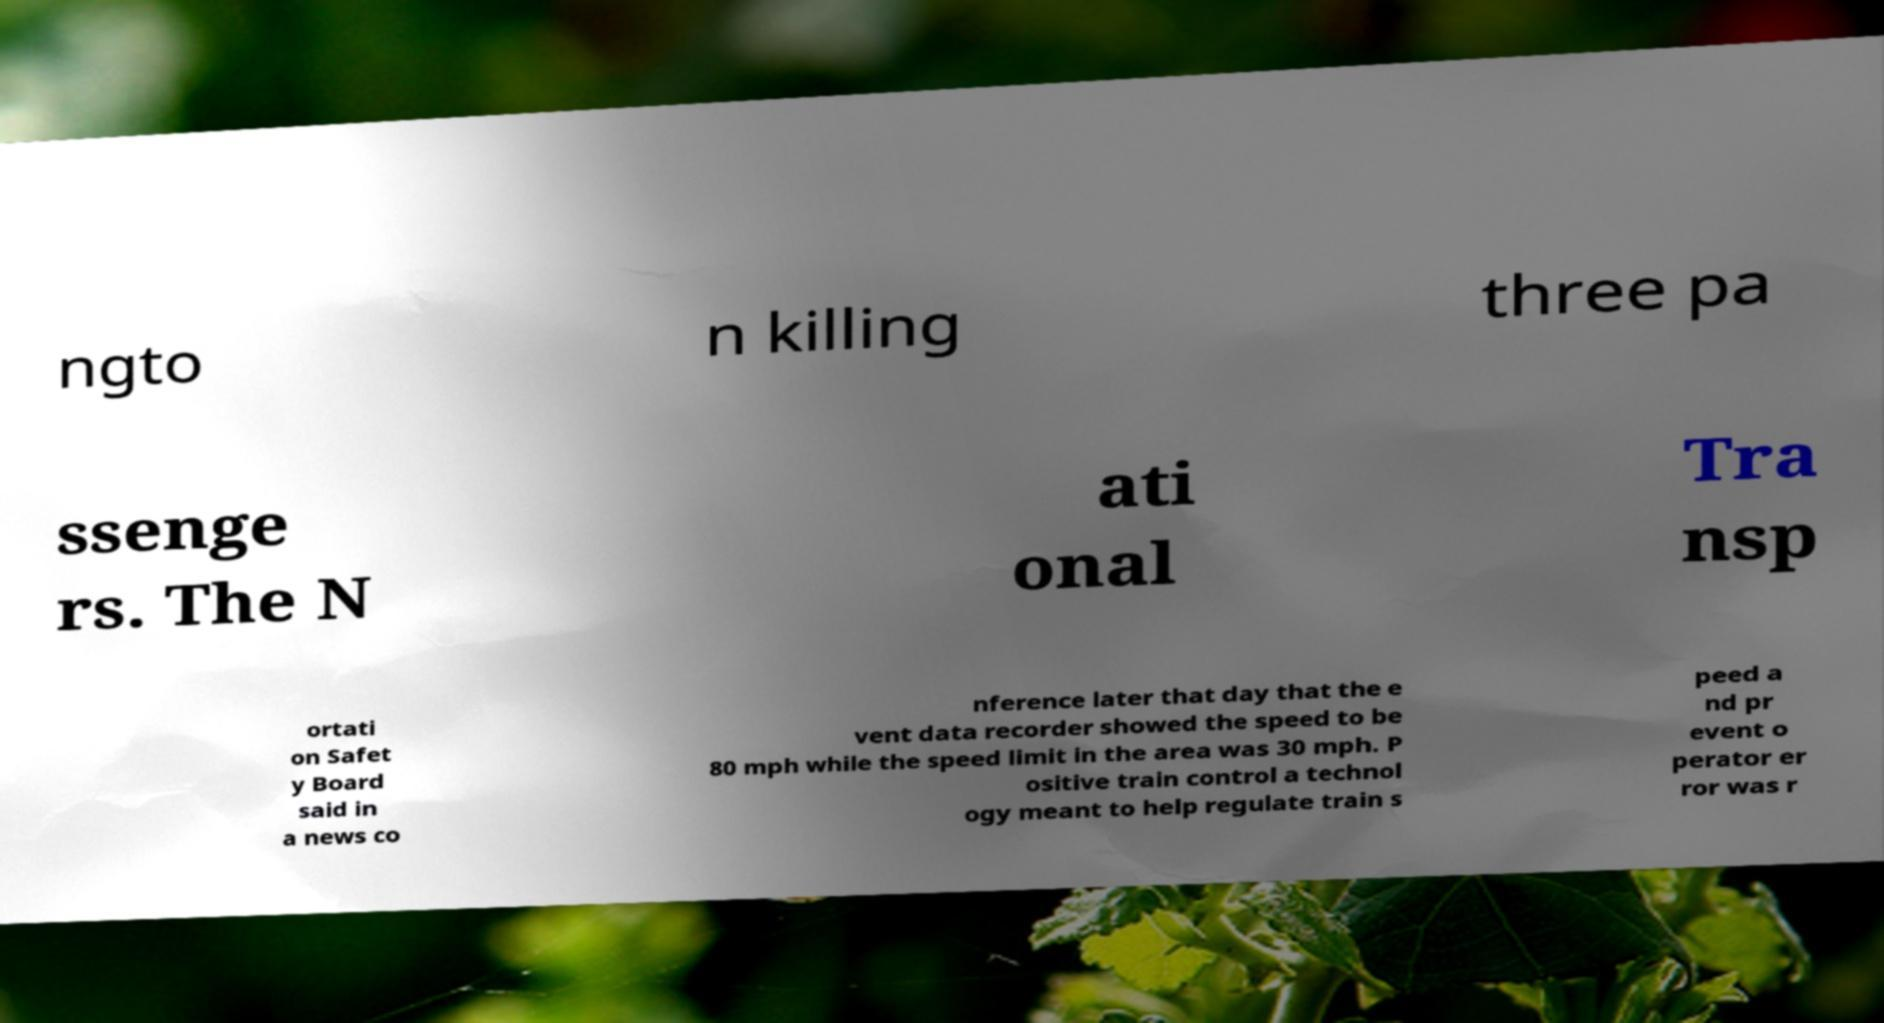Can you read and provide the text displayed in the image?This photo seems to have some interesting text. Can you extract and type it out for me? ngto n killing three pa ssenge rs. The N ati onal Tra nsp ortati on Safet y Board said in a news co nference later that day that the e vent data recorder showed the speed to be 80 mph while the speed limit in the area was 30 mph. P ositive train control a technol ogy meant to help regulate train s peed a nd pr event o perator er ror was r 